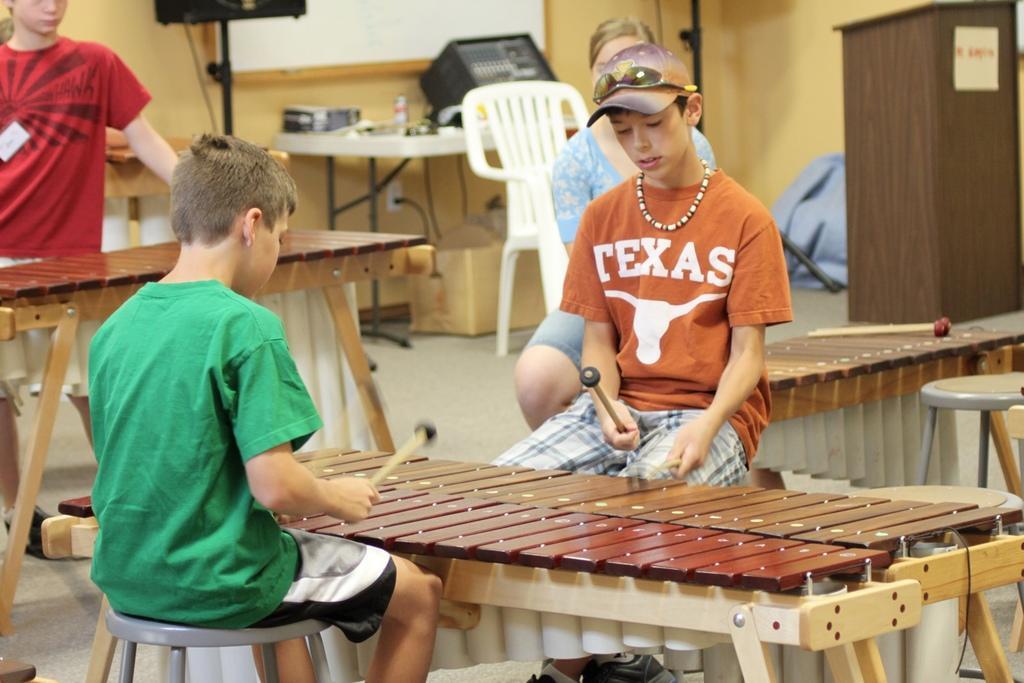Could you give a brief overview of what you see in this image? This picture describes about four people, three people are seated on the chair and one is standing, in the middle of the given image two kids are holding sticks in their hands, in the background we can see some objects on the table and a notice board. 